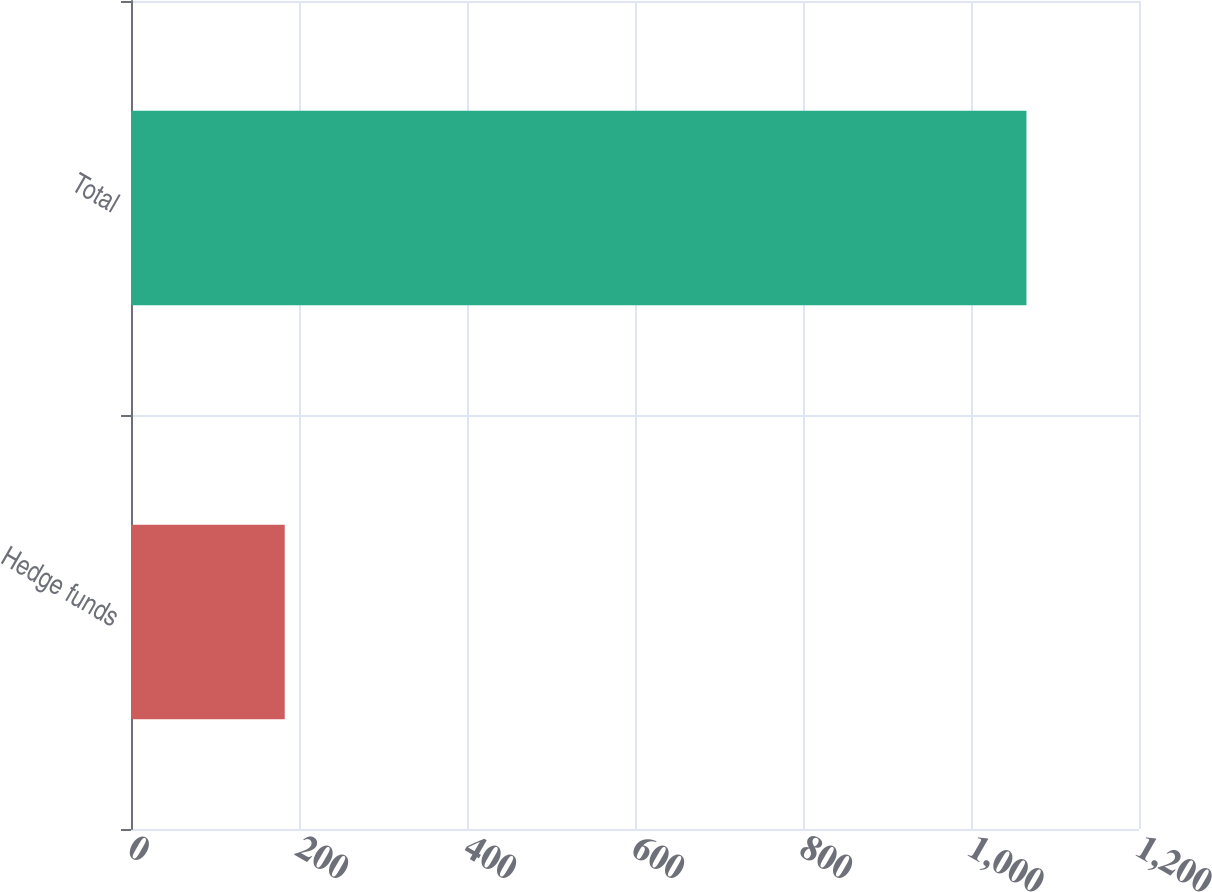Convert chart. <chart><loc_0><loc_0><loc_500><loc_500><bar_chart><fcel>Hedge funds<fcel>Total<nl><fcel>183<fcel>1066<nl></chart> 